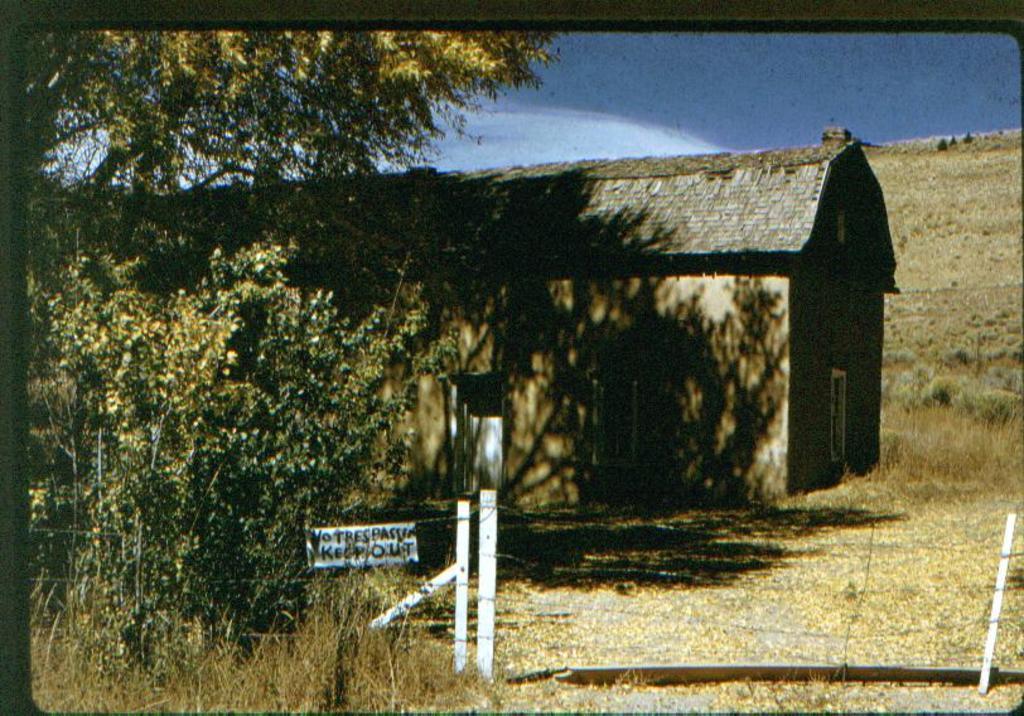Please provide a concise description of this image. In this picture, we can see house, ground with dry leaves, and we can see plants, trees, fencing, board with some text and the sky with clouds. 